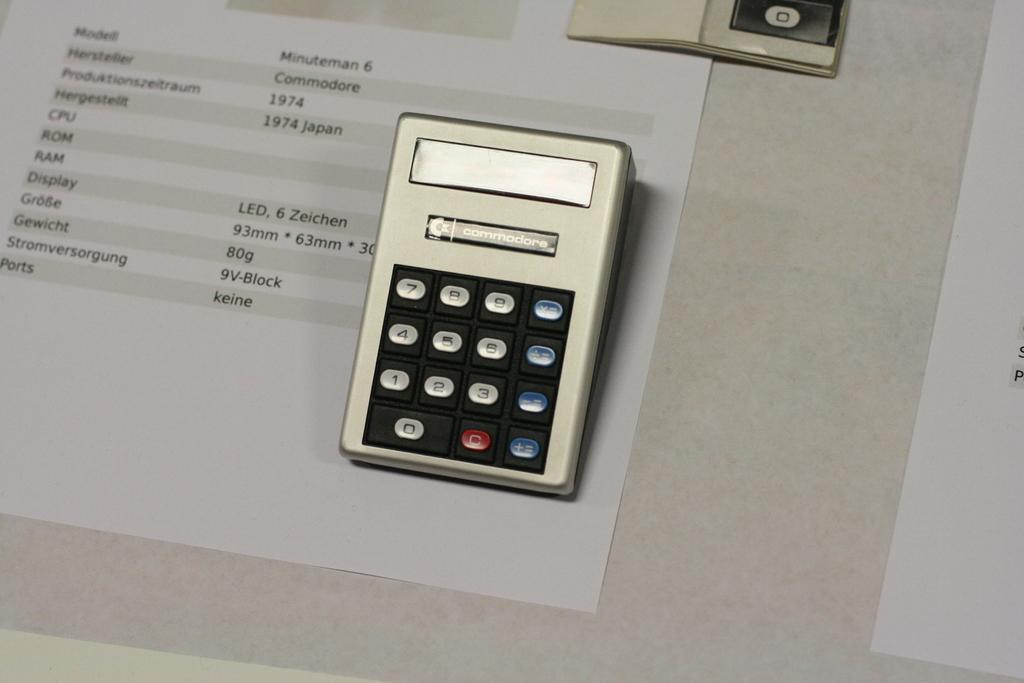Can you describe this image briefly? In the center of the image there is a calculator and papers placed on the table. 